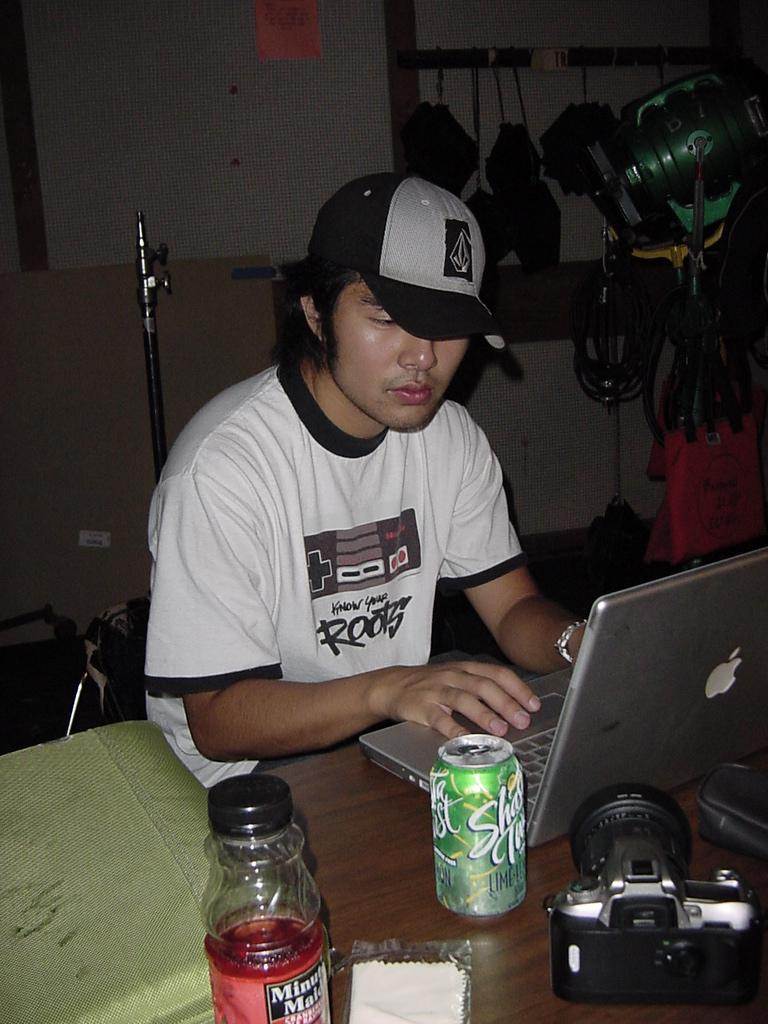What is the person in the image doing? The person is sitting and typing. Can you describe the person's attire? The person is wearing a cap. What object is on the table in front of the person? There is a laptop on the table. Are there any other objects on the table? Yes, there is a tin, a bottle, and a camera on the table. What can be seen in the background of the image? There is a wall, a stand, and cables in the background. What type of verse is the person reciting in the image? There is no indication in the image that the person is reciting a verse, as they are sitting and typing. What grade of brick is visible in the image? There are no bricks present in the image; it features a person sitting at a table with various objects. 